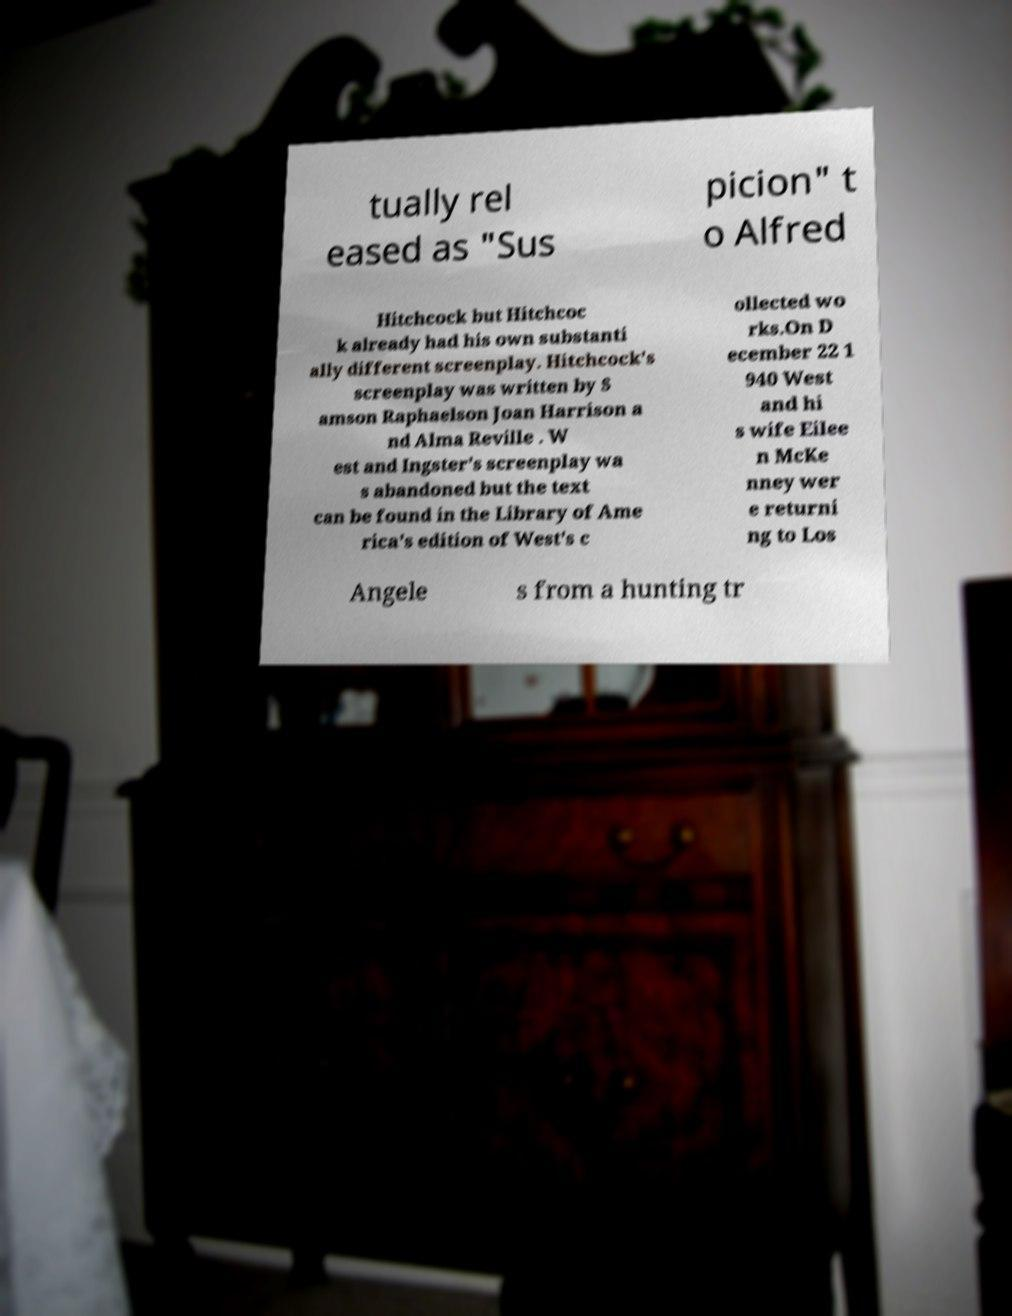Could you assist in decoding the text presented in this image and type it out clearly? tually rel eased as "Sus picion" t o Alfred Hitchcock but Hitchcoc k already had his own substanti ally different screenplay. Hitchcock's screenplay was written by S amson Raphaelson Joan Harrison a nd Alma Reville . W est and Ingster's screenplay wa s abandoned but the text can be found in the Library of Ame rica's edition of West's c ollected wo rks.On D ecember 22 1 940 West and hi s wife Eilee n McKe nney wer e returni ng to Los Angele s from a hunting tr 